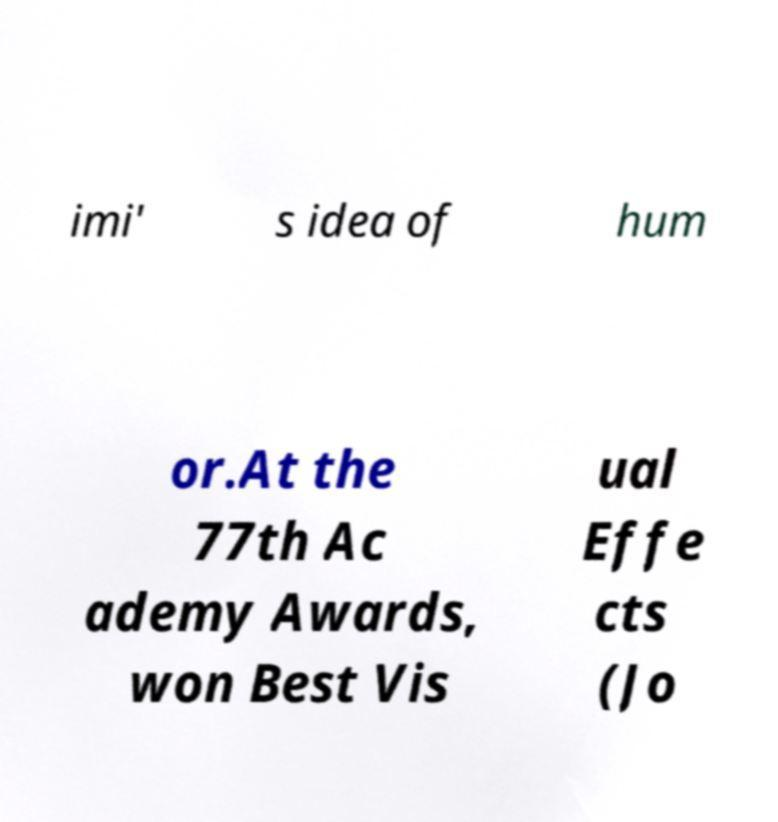What messages or text are displayed in this image? I need them in a readable, typed format. imi' s idea of hum or.At the 77th Ac ademy Awards, won Best Vis ual Effe cts (Jo 